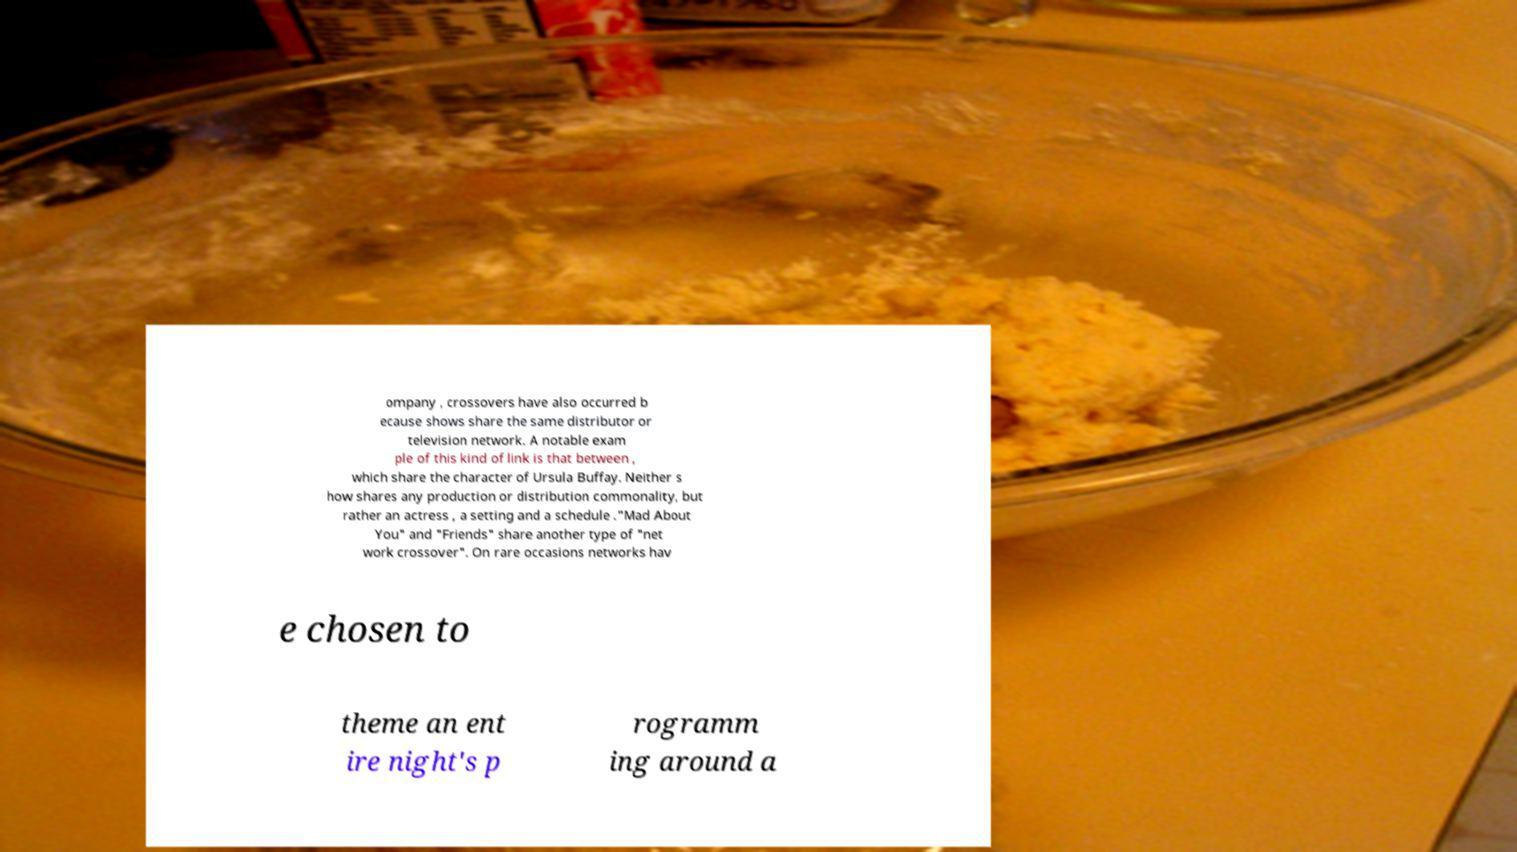Can you accurately transcribe the text from the provided image for me? ompany , crossovers have also occurred b ecause shows share the same distributor or television network. A notable exam ple of this kind of link is that between , which share the character of Ursula Buffay. Neither s how shares any production or distribution commonality, but rather an actress , a setting and a schedule ."Mad About You" and "Friends" share another type of "net work crossover". On rare occasions networks hav e chosen to theme an ent ire night's p rogramm ing around a 